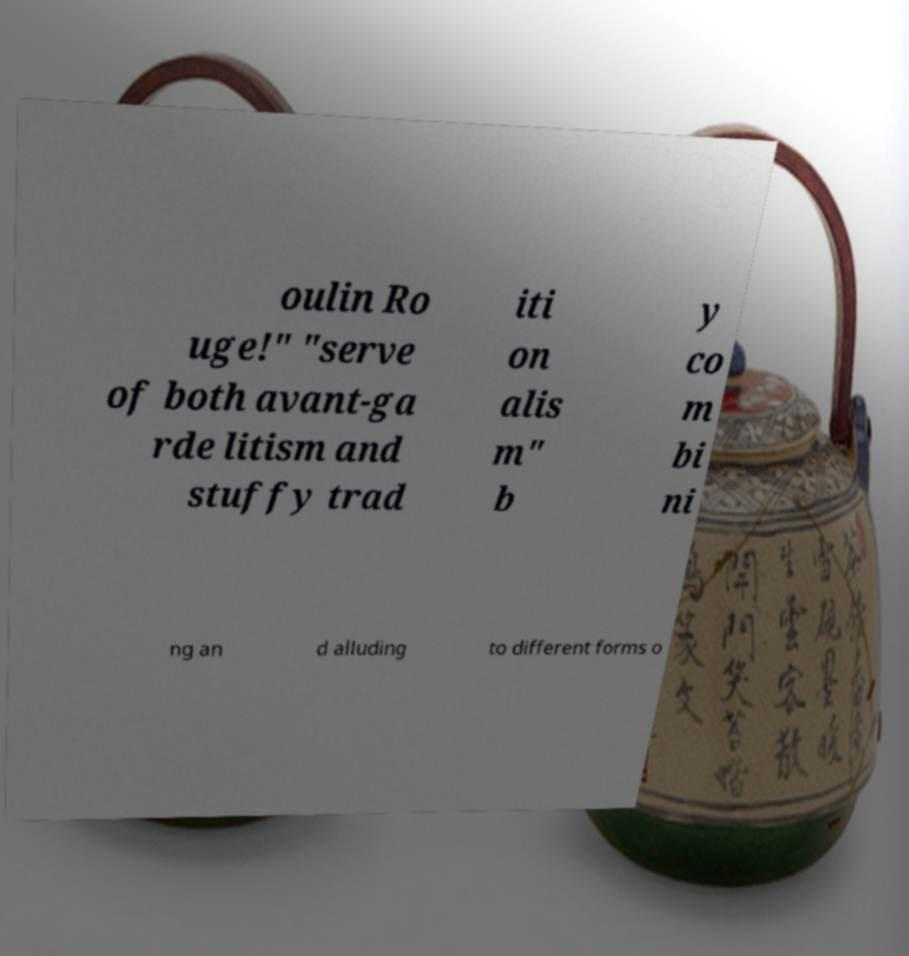Can you accurately transcribe the text from the provided image for me? oulin Ro uge!" "serve of both avant-ga rde litism and stuffy trad iti on alis m" b y co m bi ni ng an d alluding to different forms o 